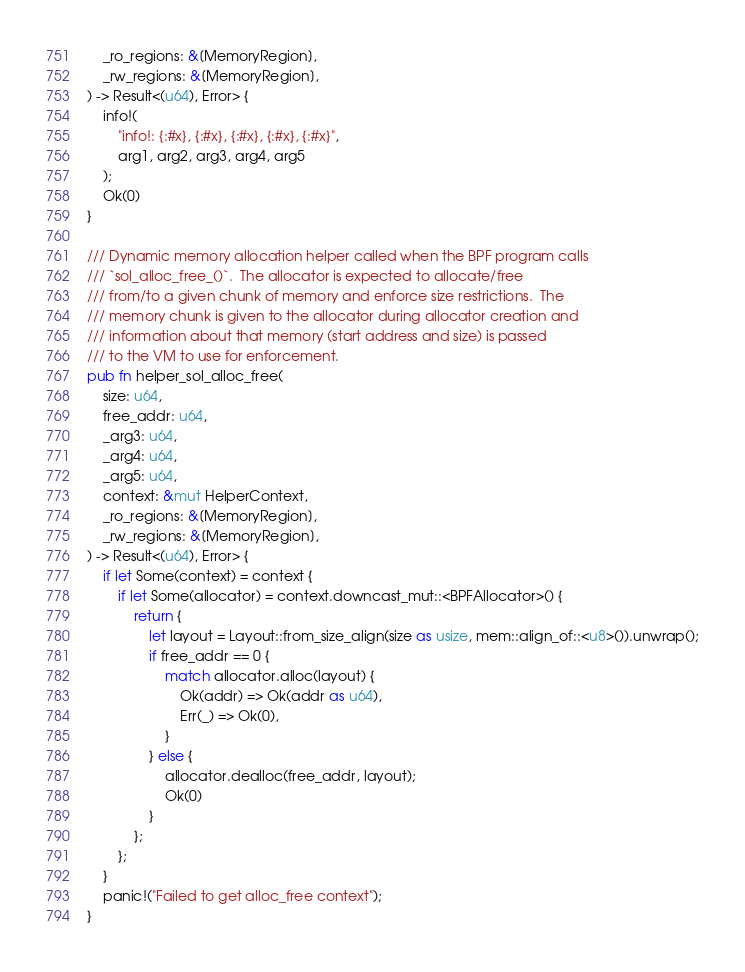Convert code to text. <code><loc_0><loc_0><loc_500><loc_500><_Rust_>    _ro_regions: &[MemoryRegion],
    _rw_regions: &[MemoryRegion],
) -> Result<(u64), Error> {
    info!(
        "info!: {:#x}, {:#x}, {:#x}, {:#x}, {:#x}",
        arg1, arg2, arg3, arg4, arg5
    );
    Ok(0)
}

/// Dynamic memory allocation helper called when the BPF program calls
/// `sol_alloc_free_()`.  The allocator is expected to allocate/free
/// from/to a given chunk of memory and enforce size restrictions.  The
/// memory chunk is given to the allocator during allocator creation and
/// information about that memory (start address and size) is passed
/// to the VM to use for enforcement.
pub fn helper_sol_alloc_free(
    size: u64,
    free_addr: u64,
    _arg3: u64,
    _arg4: u64,
    _arg5: u64,
    context: &mut HelperContext,
    _ro_regions: &[MemoryRegion],
    _rw_regions: &[MemoryRegion],
) -> Result<(u64), Error> {
    if let Some(context) = context {
        if let Some(allocator) = context.downcast_mut::<BPFAllocator>() {
            return {
                let layout = Layout::from_size_align(size as usize, mem::align_of::<u8>()).unwrap();
                if free_addr == 0 {
                    match allocator.alloc(layout) {
                        Ok(addr) => Ok(addr as u64),
                        Err(_) => Ok(0),
                    }
                } else {
                    allocator.dealloc(free_addr, layout);
                    Ok(0)
                }
            };
        };
    }
    panic!("Failed to get alloc_free context");
}
</code> 